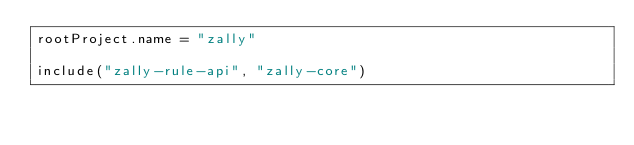Convert code to text. <code><loc_0><loc_0><loc_500><loc_500><_Kotlin_>rootProject.name = "zally"

include("zally-rule-api", "zally-core")
</code> 